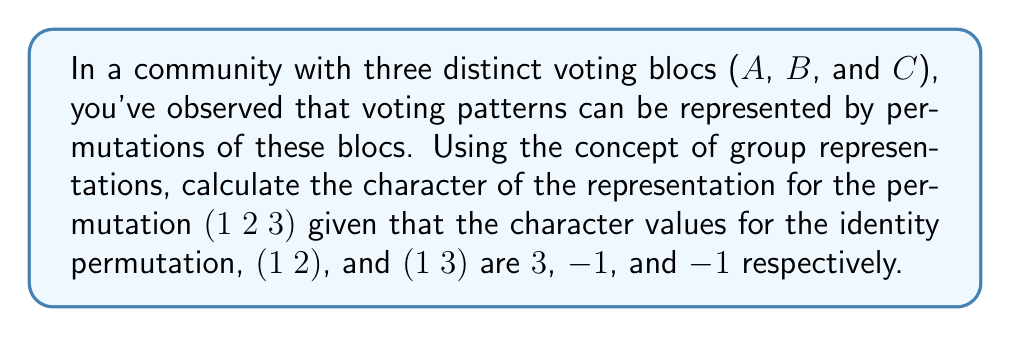Can you answer this question? Let's approach this step-by-step:

1) First, recall that the character of a representation is the trace of the matrix representing each group element.

2) We're given a representation of the symmetric group $S_3$, which has 6 elements: $e, (1 2), (1 3), (2 3), (1 2 3), (1 3 2)$.

3) We're given the following character values:
   $\chi(e) = 3$
   $\chi((1 2)) = -1$
   $\chi((1 3)) = -1$

4) In $S_3$, there are three conjugacy classes:
   $\{e\}$, $\{(1 2), (1 3), (2 3)\}$, and $\{(1 2 3), (1 3 2)\}$

5) Characters are constant on conjugacy classes. So, $\chi((2 3)) = -1$ as well.

6) Now, we can use the property that the sum of characters over all group elements is zero for any non-trivial irreducible representation:

   $$\chi(e) + \chi((1 2)) + \chi((1 3)) + \chi((2 3)) + \chi((1 2 3)) + \chi((1 3 2)) = 0$$

7) Substituting the known values:

   $$3 + (-1) + (-1) + (-1) + \chi((1 2 3)) + \chi((1 3 2)) = 0$$

8) Since (1 2 3) and (1 3 2) are in the same conjugacy class, their character values are the same. Let's call this value $x$:

   $$3 + (-1) + (-1) + (-1) + x + x = 0$$

9) Simplifying:

   $$0 + 2x = 0$$
   $$2x = 0$$
   $$x = 0$$

Therefore, the character value for (1 2 3) is 0.
Answer: 0 